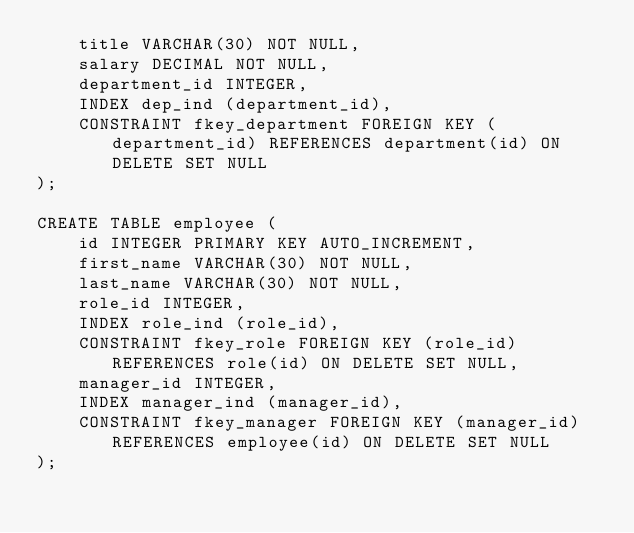<code> <loc_0><loc_0><loc_500><loc_500><_SQL_>    title VARCHAR(30) NOT NULL, 
    salary DECIMAL NOT NULL,
    department_id INTEGER, 
    INDEX dep_ind (department_id),
    CONSTRAINT fkey_department FOREIGN KEY (department_id) REFERENCES department(id) ON DELETE SET NULL
);

CREATE TABLE employee (
    id INTEGER PRIMARY KEY AUTO_INCREMENT,
    first_name VARCHAR(30) NOT NULL,
    last_name VARCHAR(30) NOT NULL,
    role_id INTEGER, 
    INDEX role_ind (role_id),
    CONSTRAINT fkey_role FOREIGN KEY (role_id) REFERENCES role(id) ON DELETE SET NULL,
    manager_id INTEGER,
    INDEX manager_ind (manager_id),
    CONSTRAINT fkey_manager FOREIGN KEY (manager_id) REFERENCES employee(id) ON DELETE SET NULL
);</code> 